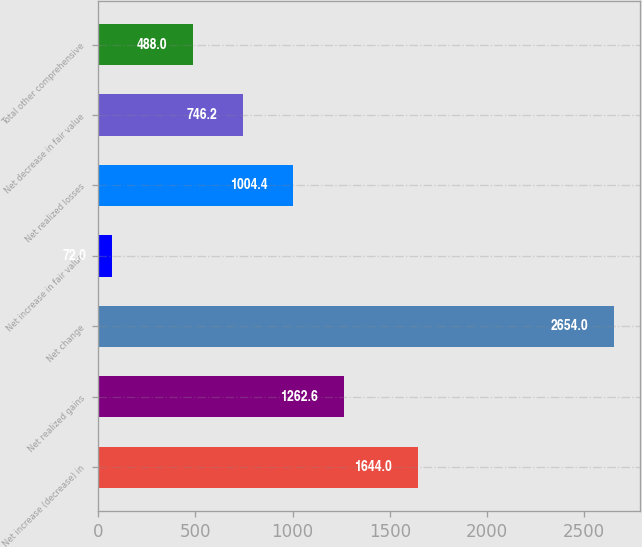Convert chart. <chart><loc_0><loc_0><loc_500><loc_500><bar_chart><fcel>Net increase (decrease) in<fcel>Net realized gains<fcel>Net change<fcel>Net increase in fair value<fcel>Net realized losses<fcel>Net decrease in fair value<fcel>Total other comprehensive<nl><fcel>1644<fcel>1262.6<fcel>2654<fcel>72<fcel>1004.4<fcel>746.2<fcel>488<nl></chart> 